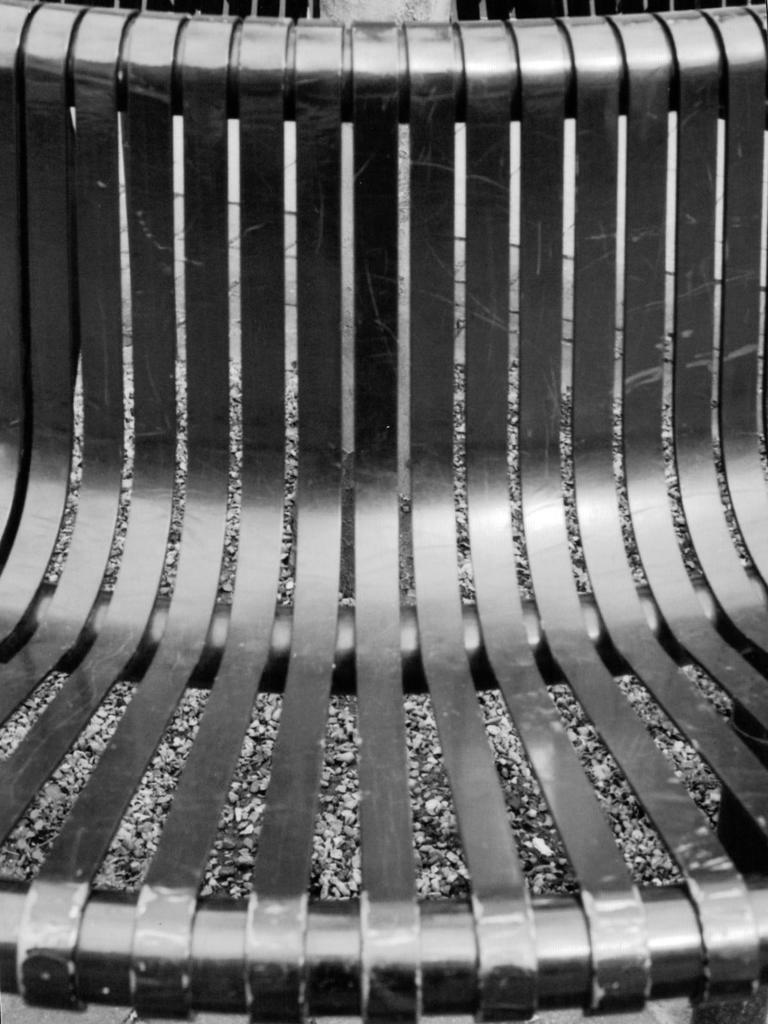What type of chair is in the image? There is a metal chair in the image. What type of natural elements can be seen in the image? There are stones visible in the image. What is located at the top of the image? There are objects at the top of the image. What type of pollution is visible in the image? There is no pollution visible in the image. How does the elbow contribute to the image? There is no mention of an elbow in the image, so it does not contribute to the image. 